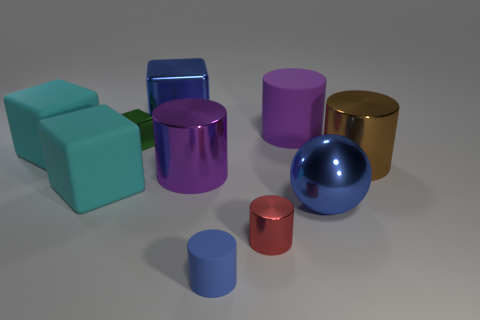Can you tell me which objects stand out the most due to their size and why? In the image, the large blue sphere and the gold cylinder stand out the most because of their size. Their larger dimensions in relation to the other objects draw the eye, making them prominent features of the visual composition. 